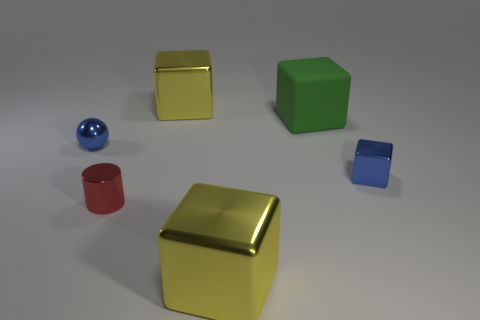Are there any other big metal things of the same shape as the green object?
Your response must be concise. Yes. What is the big thing that is on the left side of the large metallic object that is to the right of the big yellow block that is behind the matte block made of?
Offer a terse response. Metal. The shiny cylinder is what color?
Offer a terse response. Red. How many matte objects are red things or brown cylinders?
Keep it short and to the point. 0. Is there any other thing that is the same material as the red thing?
Make the answer very short. Yes. There is a blue shiny object that is to the right of the big yellow block that is behind the yellow thing in front of the small ball; how big is it?
Your response must be concise. Small. What is the size of the cube that is both to the left of the small blue block and in front of the large green matte object?
Your response must be concise. Large. Is the color of the big block in front of the red cylinder the same as the big metallic object behind the tiny red metal cylinder?
Offer a terse response. Yes. What number of green things are left of the tiny blue block?
Your answer should be very brief. 1. Is there a big shiny thing that is on the left side of the tiny blue object on the left side of the yellow shiny thing that is in front of the matte thing?
Your response must be concise. No. 